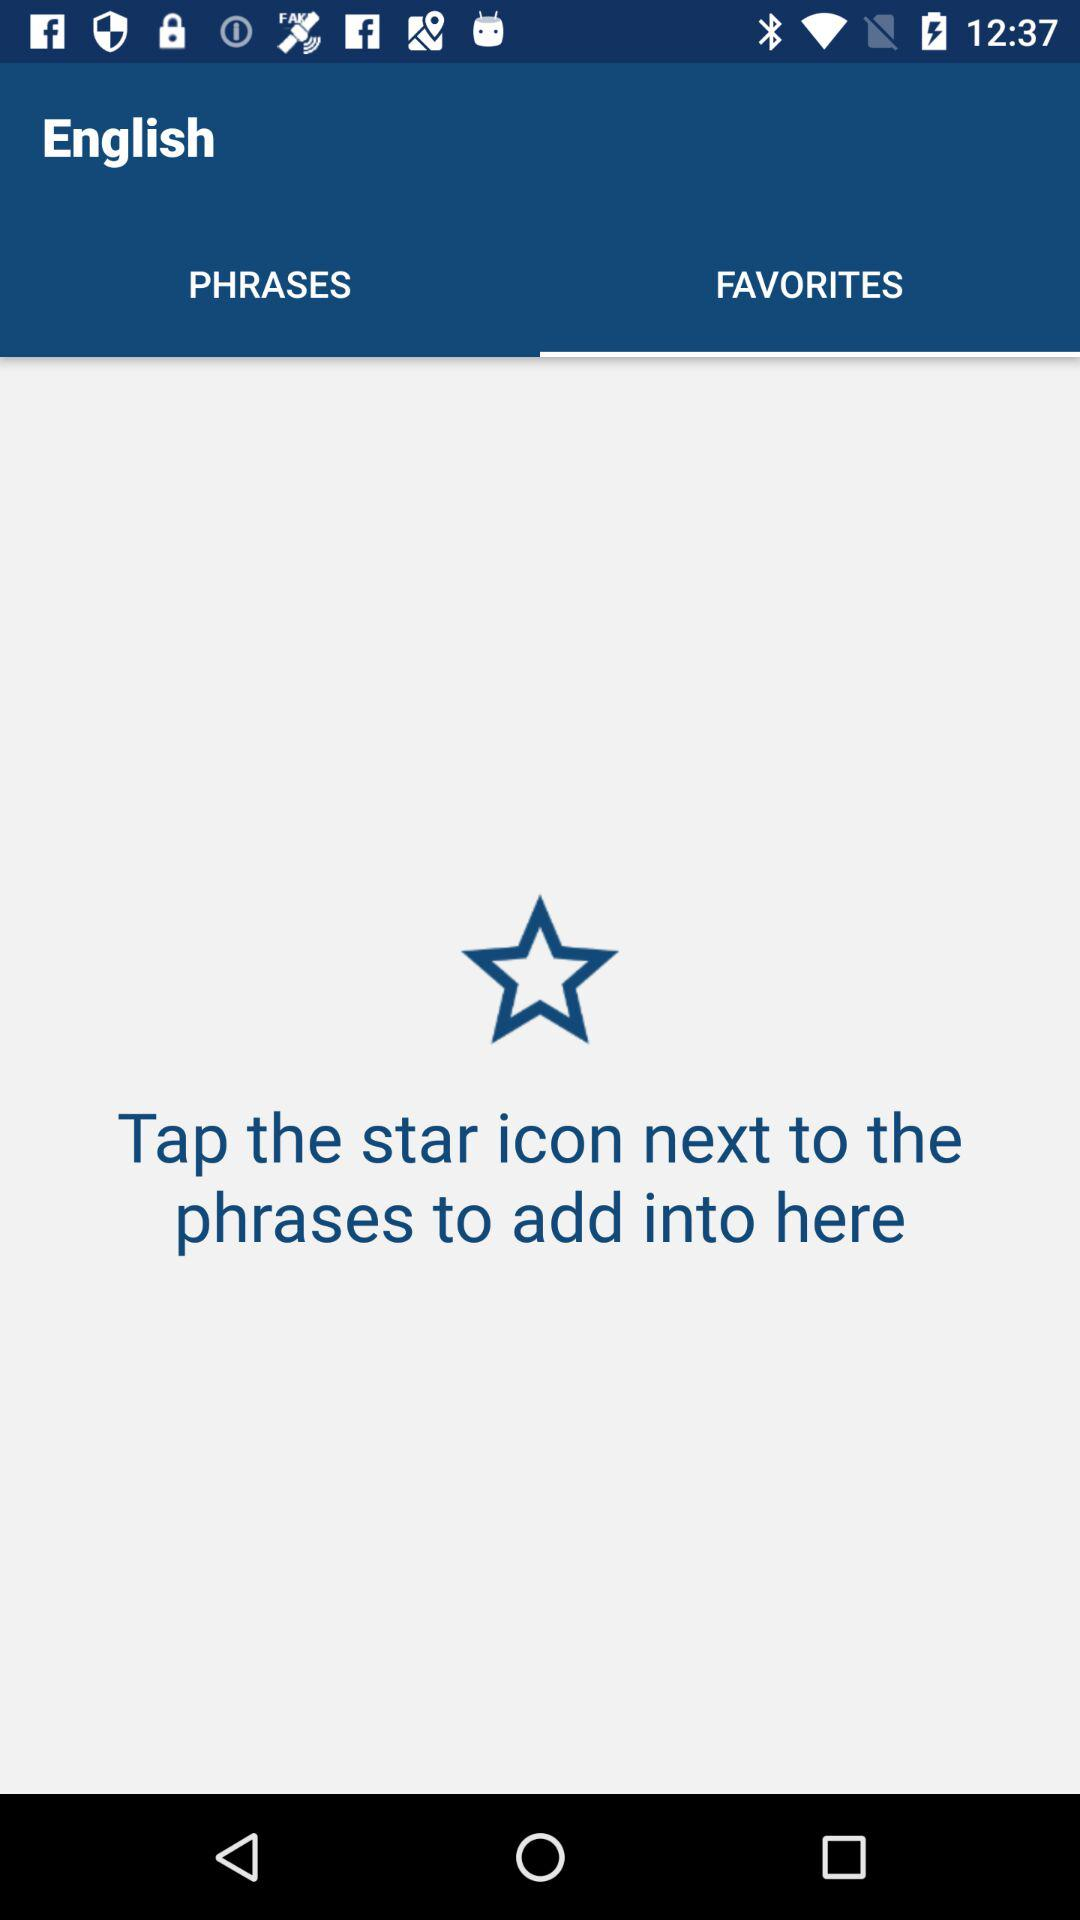What is the selected language? The selected language is "English". 